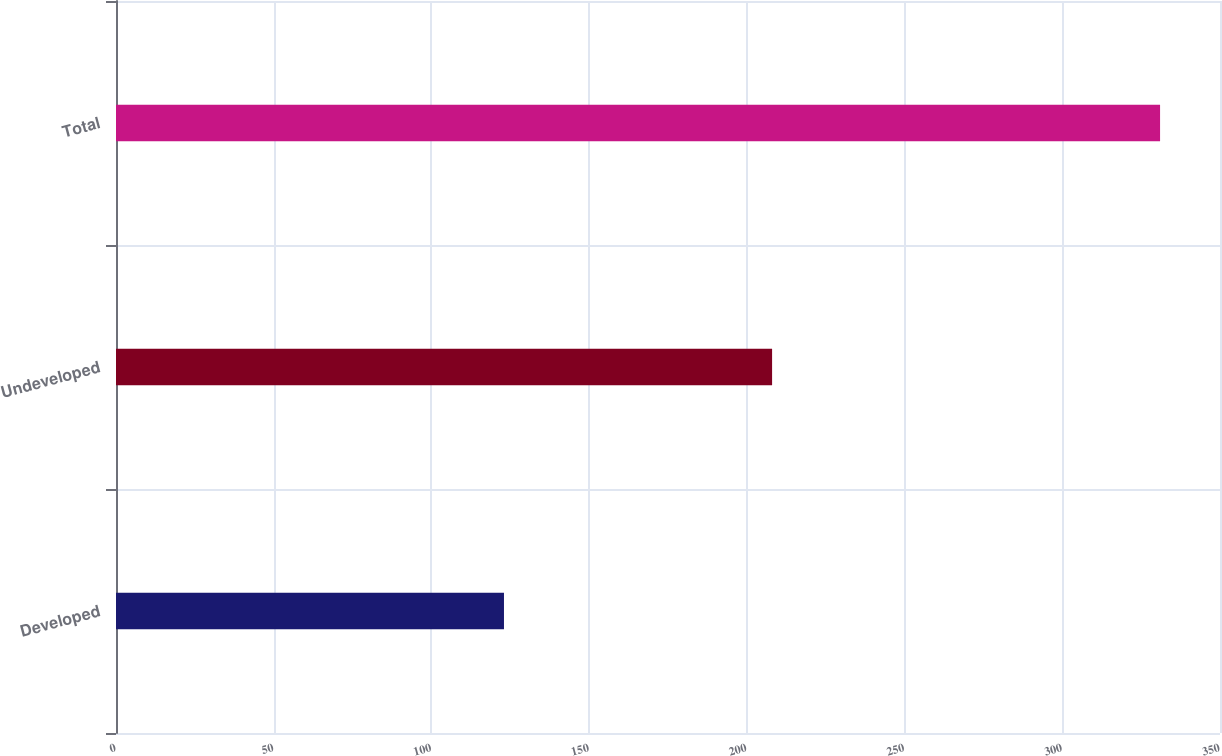Convert chart. <chart><loc_0><loc_0><loc_500><loc_500><bar_chart><fcel>Developed<fcel>Undeveloped<fcel>Total<nl><fcel>123<fcel>208<fcel>331<nl></chart> 